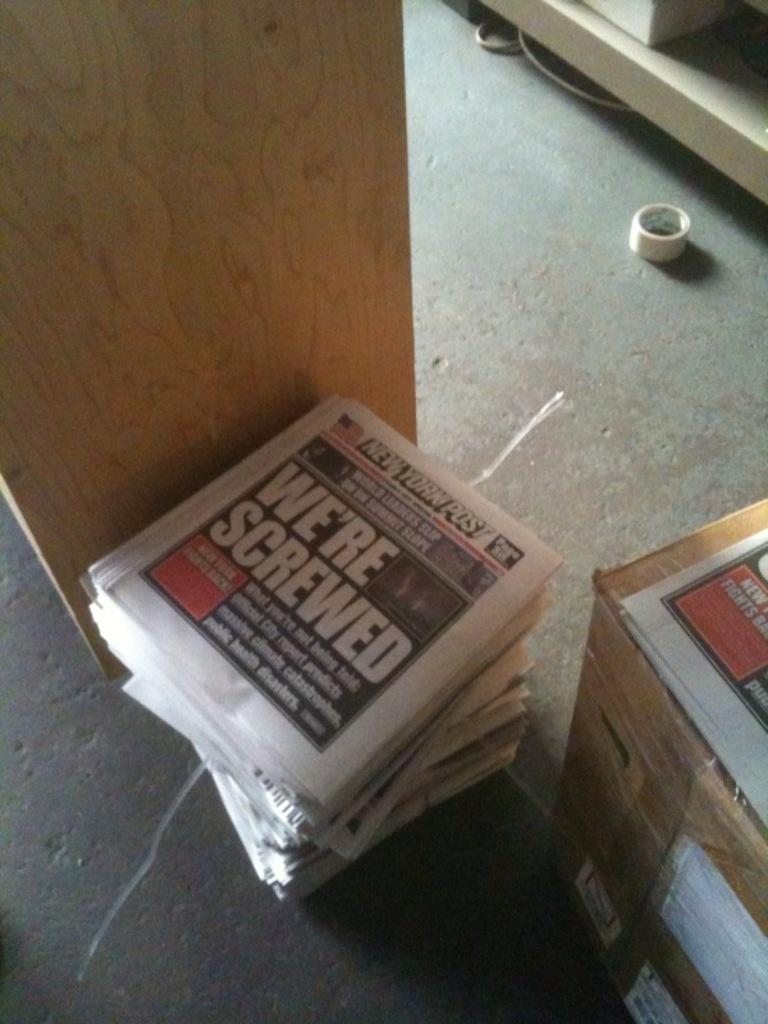<image>
Share a concise interpretation of the image provided. A stack of copies of the New York Post with a large headline reading 'we're screwed' 